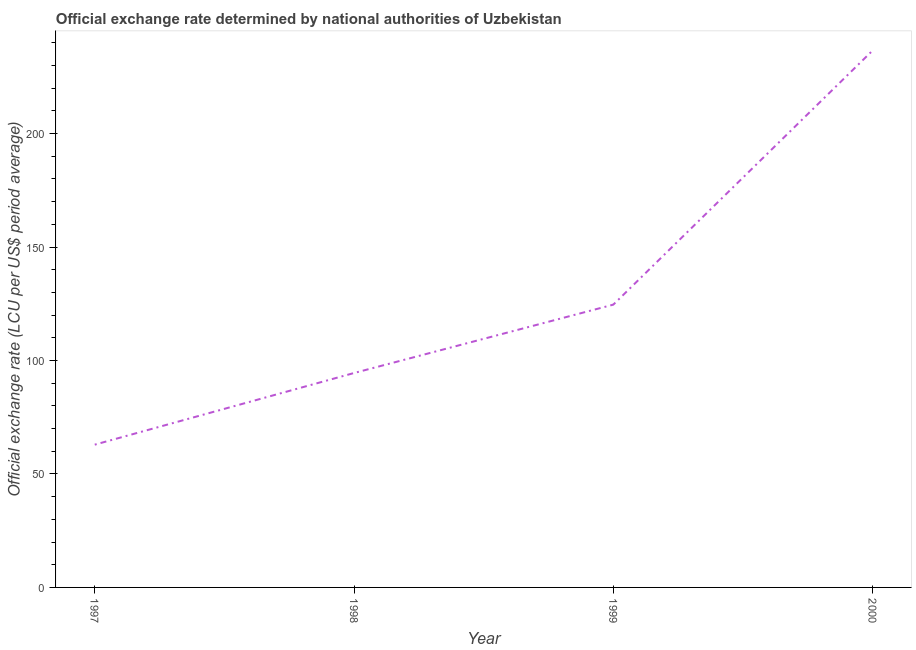What is the official exchange rate in 2000?
Your response must be concise. 236.61. Across all years, what is the maximum official exchange rate?
Give a very brief answer. 236.61. Across all years, what is the minimum official exchange rate?
Your answer should be compact. 62.92. What is the sum of the official exchange rate?
Ensure brevity in your answer.  518.64. What is the difference between the official exchange rate in 1997 and 1998?
Your answer should be compact. -31.58. What is the average official exchange rate per year?
Your response must be concise. 129.66. What is the median official exchange rate?
Provide a short and direct response. 109.56. What is the ratio of the official exchange rate in 1998 to that in 1999?
Offer a very short reply. 0.76. Is the difference between the official exchange rate in 1998 and 2000 greater than the difference between any two years?
Offer a terse response. No. What is the difference between the highest and the second highest official exchange rate?
Offer a terse response. 111.98. What is the difference between the highest and the lowest official exchange rate?
Offer a terse response. 173.69. In how many years, is the official exchange rate greater than the average official exchange rate taken over all years?
Ensure brevity in your answer.  1. Does the official exchange rate monotonically increase over the years?
Provide a short and direct response. Yes. How many lines are there?
Offer a terse response. 1. What is the difference between two consecutive major ticks on the Y-axis?
Make the answer very short. 50. Are the values on the major ticks of Y-axis written in scientific E-notation?
Ensure brevity in your answer.  No. Does the graph contain grids?
Make the answer very short. No. What is the title of the graph?
Give a very brief answer. Official exchange rate determined by national authorities of Uzbekistan. What is the label or title of the Y-axis?
Provide a succinct answer. Official exchange rate (LCU per US$ period average). What is the Official exchange rate (LCU per US$ period average) of 1997?
Offer a very short reply. 62.92. What is the Official exchange rate (LCU per US$ period average) in 1998?
Keep it short and to the point. 94.49. What is the Official exchange rate (LCU per US$ period average) of 1999?
Ensure brevity in your answer.  124.62. What is the Official exchange rate (LCU per US$ period average) in 2000?
Ensure brevity in your answer.  236.61. What is the difference between the Official exchange rate (LCU per US$ period average) in 1997 and 1998?
Make the answer very short. -31.57. What is the difference between the Official exchange rate (LCU per US$ period average) in 1997 and 1999?
Your response must be concise. -61.71. What is the difference between the Official exchange rate (LCU per US$ period average) in 1997 and 2000?
Give a very brief answer. -173.69. What is the difference between the Official exchange rate (LCU per US$ period average) in 1998 and 1999?
Keep it short and to the point. -30.13. What is the difference between the Official exchange rate (LCU per US$ period average) in 1998 and 2000?
Provide a succinct answer. -142.12. What is the difference between the Official exchange rate (LCU per US$ period average) in 1999 and 2000?
Your answer should be compact. -111.98. What is the ratio of the Official exchange rate (LCU per US$ period average) in 1997 to that in 1998?
Make the answer very short. 0.67. What is the ratio of the Official exchange rate (LCU per US$ period average) in 1997 to that in 1999?
Keep it short and to the point. 0.51. What is the ratio of the Official exchange rate (LCU per US$ period average) in 1997 to that in 2000?
Provide a succinct answer. 0.27. What is the ratio of the Official exchange rate (LCU per US$ period average) in 1998 to that in 1999?
Offer a very short reply. 0.76. What is the ratio of the Official exchange rate (LCU per US$ period average) in 1998 to that in 2000?
Offer a very short reply. 0.4. What is the ratio of the Official exchange rate (LCU per US$ period average) in 1999 to that in 2000?
Provide a short and direct response. 0.53. 